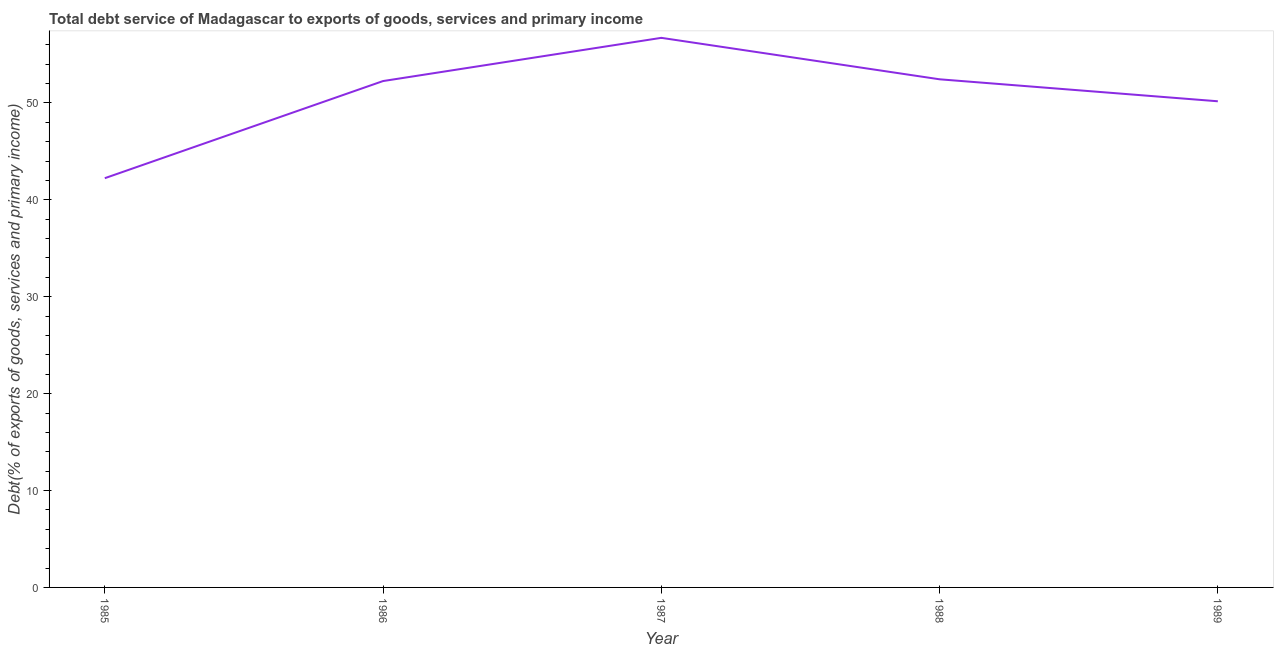What is the total debt service in 1989?
Your response must be concise. 50.17. Across all years, what is the maximum total debt service?
Your response must be concise. 56.72. Across all years, what is the minimum total debt service?
Your answer should be very brief. 42.24. In which year was the total debt service maximum?
Ensure brevity in your answer.  1987. In which year was the total debt service minimum?
Offer a terse response. 1985. What is the sum of the total debt service?
Keep it short and to the point. 253.83. What is the difference between the total debt service in 1985 and 1988?
Your answer should be very brief. -10.21. What is the average total debt service per year?
Your response must be concise. 50.77. What is the median total debt service?
Offer a terse response. 52.26. What is the ratio of the total debt service in 1987 to that in 1988?
Make the answer very short. 1.08. Is the difference between the total debt service in 1987 and 1988 greater than the difference between any two years?
Give a very brief answer. No. What is the difference between the highest and the second highest total debt service?
Make the answer very short. 4.28. What is the difference between the highest and the lowest total debt service?
Make the answer very short. 14.48. How many lines are there?
Your answer should be compact. 1. How many years are there in the graph?
Your response must be concise. 5. What is the difference between two consecutive major ticks on the Y-axis?
Offer a terse response. 10. Are the values on the major ticks of Y-axis written in scientific E-notation?
Offer a very short reply. No. Does the graph contain grids?
Offer a very short reply. No. What is the title of the graph?
Offer a very short reply. Total debt service of Madagascar to exports of goods, services and primary income. What is the label or title of the Y-axis?
Your answer should be very brief. Debt(% of exports of goods, services and primary income). What is the Debt(% of exports of goods, services and primary income) of 1985?
Your response must be concise. 42.24. What is the Debt(% of exports of goods, services and primary income) in 1986?
Make the answer very short. 52.26. What is the Debt(% of exports of goods, services and primary income) of 1987?
Your answer should be very brief. 56.72. What is the Debt(% of exports of goods, services and primary income) in 1988?
Give a very brief answer. 52.44. What is the Debt(% of exports of goods, services and primary income) of 1989?
Provide a short and direct response. 50.17. What is the difference between the Debt(% of exports of goods, services and primary income) in 1985 and 1986?
Ensure brevity in your answer.  -10.03. What is the difference between the Debt(% of exports of goods, services and primary income) in 1985 and 1987?
Offer a terse response. -14.48. What is the difference between the Debt(% of exports of goods, services and primary income) in 1985 and 1988?
Make the answer very short. -10.21. What is the difference between the Debt(% of exports of goods, services and primary income) in 1985 and 1989?
Provide a succinct answer. -7.94. What is the difference between the Debt(% of exports of goods, services and primary income) in 1986 and 1987?
Provide a succinct answer. -4.46. What is the difference between the Debt(% of exports of goods, services and primary income) in 1986 and 1988?
Your answer should be very brief. -0.18. What is the difference between the Debt(% of exports of goods, services and primary income) in 1986 and 1989?
Your answer should be very brief. 2.09. What is the difference between the Debt(% of exports of goods, services and primary income) in 1987 and 1988?
Ensure brevity in your answer.  4.28. What is the difference between the Debt(% of exports of goods, services and primary income) in 1987 and 1989?
Your answer should be very brief. 6.55. What is the difference between the Debt(% of exports of goods, services and primary income) in 1988 and 1989?
Give a very brief answer. 2.27. What is the ratio of the Debt(% of exports of goods, services and primary income) in 1985 to that in 1986?
Your answer should be compact. 0.81. What is the ratio of the Debt(% of exports of goods, services and primary income) in 1985 to that in 1987?
Provide a short and direct response. 0.74. What is the ratio of the Debt(% of exports of goods, services and primary income) in 1985 to that in 1988?
Your response must be concise. 0.81. What is the ratio of the Debt(% of exports of goods, services and primary income) in 1985 to that in 1989?
Keep it short and to the point. 0.84. What is the ratio of the Debt(% of exports of goods, services and primary income) in 1986 to that in 1987?
Ensure brevity in your answer.  0.92. What is the ratio of the Debt(% of exports of goods, services and primary income) in 1986 to that in 1989?
Provide a succinct answer. 1.04. What is the ratio of the Debt(% of exports of goods, services and primary income) in 1987 to that in 1988?
Offer a very short reply. 1.08. What is the ratio of the Debt(% of exports of goods, services and primary income) in 1987 to that in 1989?
Make the answer very short. 1.13. What is the ratio of the Debt(% of exports of goods, services and primary income) in 1988 to that in 1989?
Your response must be concise. 1.04. 